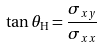Convert formula to latex. <formula><loc_0><loc_0><loc_500><loc_500>\tan \theta _ { \text {H} } = \frac { \sigma _ { x y } } { \sigma _ { x x } }</formula> 